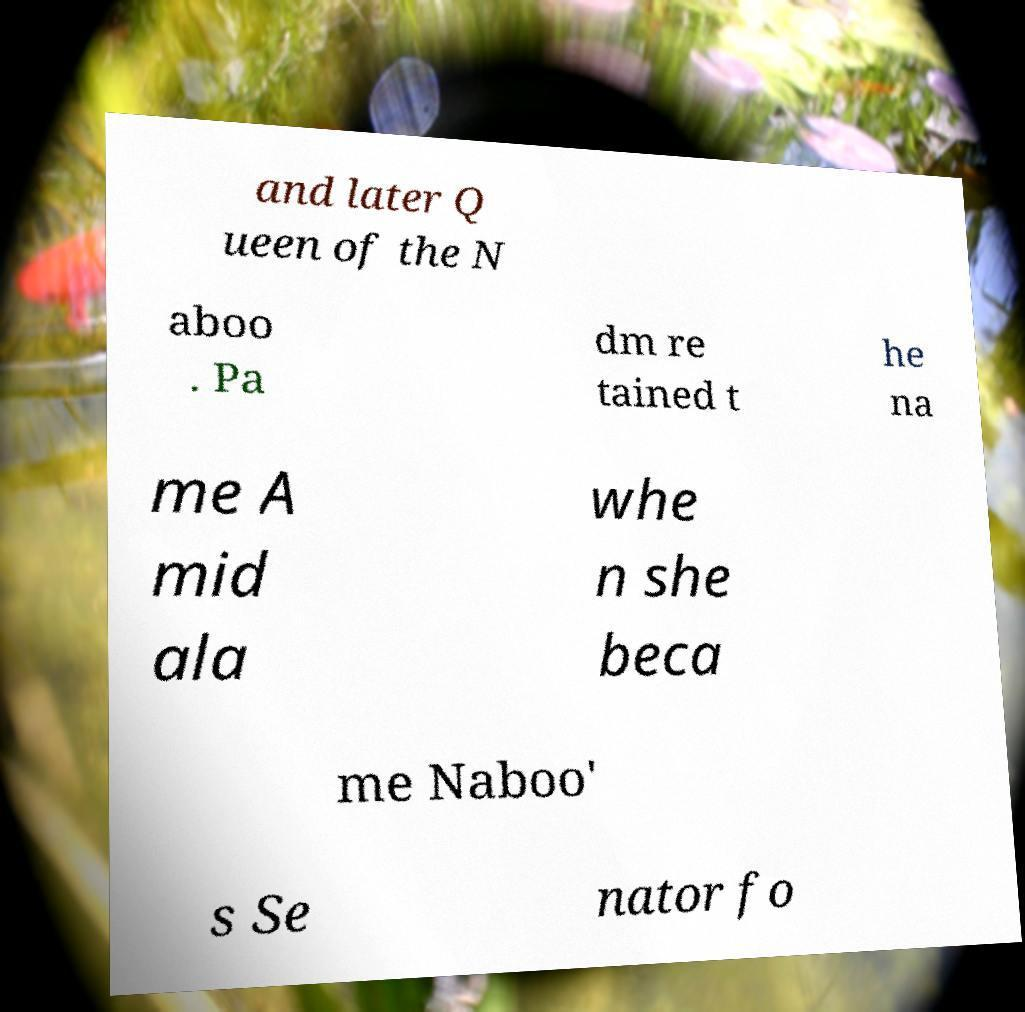There's text embedded in this image that I need extracted. Can you transcribe it verbatim? and later Q ueen of the N aboo . Pa dm re tained t he na me A mid ala whe n she beca me Naboo' s Se nator fo 